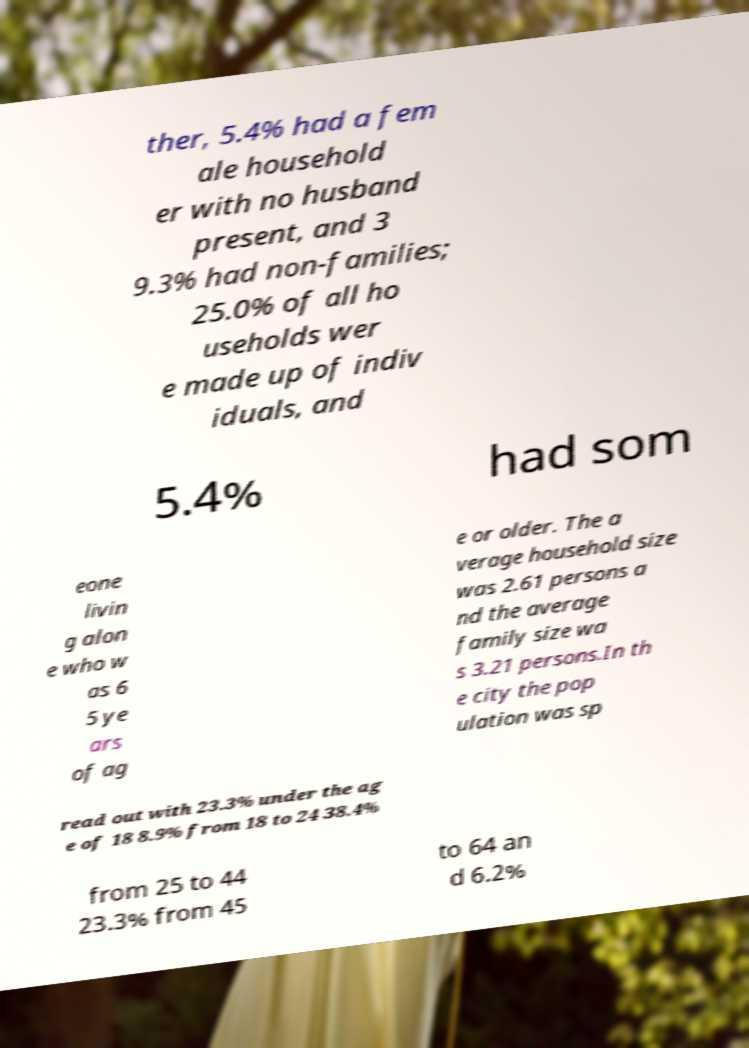There's text embedded in this image that I need extracted. Can you transcribe it verbatim? ther, 5.4% had a fem ale household er with no husband present, and 3 9.3% had non-families; 25.0% of all ho useholds wer e made up of indiv iduals, and 5.4% had som eone livin g alon e who w as 6 5 ye ars of ag e or older. The a verage household size was 2.61 persons a nd the average family size wa s 3.21 persons.In th e city the pop ulation was sp read out with 23.3% under the ag e of 18 8.9% from 18 to 24 38.4% from 25 to 44 23.3% from 45 to 64 an d 6.2% 